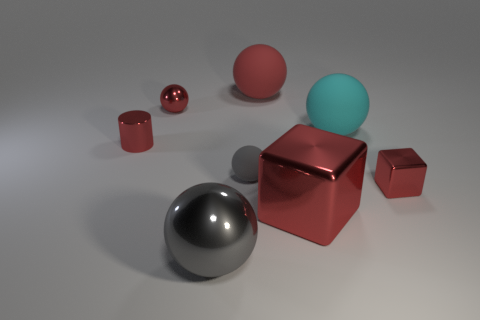How many things are cyan objects or matte things in front of the small red cylinder?
Give a very brief answer. 2. There is a gray sphere that is the same size as the red cylinder; what material is it?
Your answer should be very brief. Rubber. Are the small red cylinder and the small red block made of the same material?
Give a very brief answer. Yes. What is the color of the small metal thing that is in front of the tiny red ball and on the left side of the large red block?
Provide a succinct answer. Red. There is a big ball that is behind the cyan object; is its color the same as the small matte ball?
Your response must be concise. No. There is another red thing that is the same size as the red rubber thing; what is its shape?
Provide a succinct answer. Cube. What number of other objects are there of the same color as the small metallic block?
Your response must be concise. 4. What number of other objects are there of the same material as the small red block?
Make the answer very short. 4. There is a cylinder; does it have the same size as the gray ball that is to the left of the gray rubber object?
Your answer should be very brief. No. The large metal sphere has what color?
Offer a terse response. Gray. 